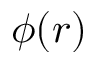Convert formula to latex. <formula><loc_0><loc_0><loc_500><loc_500>\phi ( r )</formula> 